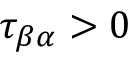<formula> <loc_0><loc_0><loc_500><loc_500>\tau _ { \beta \alpha } > 0</formula> 